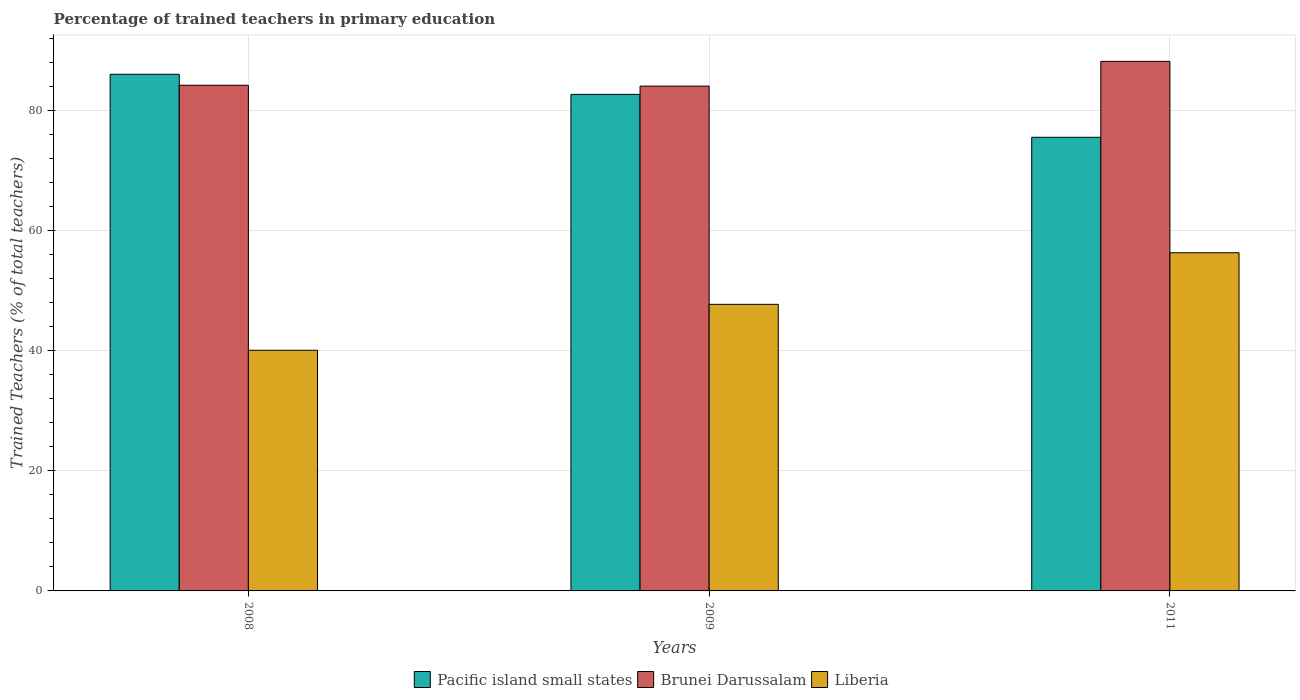How many groups of bars are there?
Offer a terse response. 3. Are the number of bars per tick equal to the number of legend labels?
Offer a terse response. Yes. Are the number of bars on each tick of the X-axis equal?
Keep it short and to the point. Yes. How many bars are there on the 2nd tick from the left?
Make the answer very short. 3. What is the percentage of trained teachers in Brunei Darussalam in 2008?
Give a very brief answer. 84.28. Across all years, what is the maximum percentage of trained teachers in Pacific island small states?
Ensure brevity in your answer.  86.11. Across all years, what is the minimum percentage of trained teachers in Brunei Darussalam?
Provide a succinct answer. 84.14. In which year was the percentage of trained teachers in Pacific island small states maximum?
Give a very brief answer. 2008. What is the total percentage of trained teachers in Pacific island small states in the graph?
Offer a very short reply. 244.49. What is the difference between the percentage of trained teachers in Brunei Darussalam in 2009 and that in 2011?
Keep it short and to the point. -4.13. What is the difference between the percentage of trained teachers in Liberia in 2011 and the percentage of trained teachers in Brunei Darussalam in 2009?
Keep it short and to the point. -27.77. What is the average percentage of trained teachers in Pacific island small states per year?
Give a very brief answer. 81.5. In the year 2008, what is the difference between the percentage of trained teachers in Pacific island small states and percentage of trained teachers in Liberia?
Offer a terse response. 46. What is the ratio of the percentage of trained teachers in Liberia in 2008 to that in 2009?
Your answer should be very brief. 0.84. Is the difference between the percentage of trained teachers in Pacific island small states in 2009 and 2011 greater than the difference between the percentage of trained teachers in Liberia in 2009 and 2011?
Offer a very short reply. Yes. What is the difference between the highest and the second highest percentage of trained teachers in Brunei Darussalam?
Offer a very short reply. 3.98. What is the difference between the highest and the lowest percentage of trained teachers in Brunei Darussalam?
Keep it short and to the point. 4.13. Is the sum of the percentage of trained teachers in Liberia in 2008 and 2011 greater than the maximum percentage of trained teachers in Brunei Darussalam across all years?
Your answer should be very brief. Yes. What does the 2nd bar from the left in 2011 represents?
Offer a very short reply. Brunei Darussalam. What does the 2nd bar from the right in 2009 represents?
Offer a terse response. Brunei Darussalam. How many bars are there?
Provide a succinct answer. 9. Are all the bars in the graph horizontal?
Your response must be concise. No. How many years are there in the graph?
Your response must be concise. 3. Does the graph contain grids?
Your answer should be compact. Yes. How many legend labels are there?
Keep it short and to the point. 3. How are the legend labels stacked?
Offer a very short reply. Horizontal. What is the title of the graph?
Keep it short and to the point. Percentage of trained teachers in primary education. What is the label or title of the Y-axis?
Provide a short and direct response. Trained Teachers (% of total teachers). What is the Trained Teachers (% of total teachers) of Pacific island small states in 2008?
Provide a short and direct response. 86.11. What is the Trained Teachers (% of total teachers) of Brunei Darussalam in 2008?
Your answer should be very brief. 84.28. What is the Trained Teachers (% of total teachers) in Liberia in 2008?
Keep it short and to the point. 40.11. What is the Trained Teachers (% of total teachers) of Pacific island small states in 2009?
Keep it short and to the point. 82.76. What is the Trained Teachers (% of total teachers) of Brunei Darussalam in 2009?
Give a very brief answer. 84.14. What is the Trained Teachers (% of total teachers) in Liberia in 2009?
Your answer should be very brief. 47.77. What is the Trained Teachers (% of total teachers) in Pacific island small states in 2011?
Your answer should be compact. 75.61. What is the Trained Teachers (% of total teachers) in Brunei Darussalam in 2011?
Your response must be concise. 88.27. What is the Trained Teachers (% of total teachers) in Liberia in 2011?
Provide a succinct answer. 56.37. Across all years, what is the maximum Trained Teachers (% of total teachers) in Pacific island small states?
Give a very brief answer. 86.11. Across all years, what is the maximum Trained Teachers (% of total teachers) in Brunei Darussalam?
Ensure brevity in your answer.  88.27. Across all years, what is the maximum Trained Teachers (% of total teachers) in Liberia?
Keep it short and to the point. 56.37. Across all years, what is the minimum Trained Teachers (% of total teachers) of Pacific island small states?
Your answer should be very brief. 75.61. Across all years, what is the minimum Trained Teachers (% of total teachers) of Brunei Darussalam?
Make the answer very short. 84.14. Across all years, what is the minimum Trained Teachers (% of total teachers) in Liberia?
Offer a terse response. 40.11. What is the total Trained Teachers (% of total teachers) in Pacific island small states in the graph?
Give a very brief answer. 244.49. What is the total Trained Teachers (% of total teachers) in Brunei Darussalam in the graph?
Ensure brevity in your answer.  256.69. What is the total Trained Teachers (% of total teachers) of Liberia in the graph?
Your answer should be compact. 144.25. What is the difference between the Trained Teachers (% of total teachers) in Pacific island small states in 2008 and that in 2009?
Offer a very short reply. 3.35. What is the difference between the Trained Teachers (% of total teachers) of Brunei Darussalam in 2008 and that in 2009?
Offer a very short reply. 0.14. What is the difference between the Trained Teachers (% of total teachers) in Liberia in 2008 and that in 2009?
Keep it short and to the point. -7.65. What is the difference between the Trained Teachers (% of total teachers) in Pacific island small states in 2008 and that in 2011?
Provide a succinct answer. 10.5. What is the difference between the Trained Teachers (% of total teachers) of Brunei Darussalam in 2008 and that in 2011?
Provide a succinct answer. -3.98. What is the difference between the Trained Teachers (% of total teachers) of Liberia in 2008 and that in 2011?
Your answer should be compact. -16.25. What is the difference between the Trained Teachers (% of total teachers) of Pacific island small states in 2009 and that in 2011?
Make the answer very short. 7.15. What is the difference between the Trained Teachers (% of total teachers) of Brunei Darussalam in 2009 and that in 2011?
Offer a very short reply. -4.13. What is the difference between the Trained Teachers (% of total teachers) in Liberia in 2009 and that in 2011?
Your answer should be very brief. -8.6. What is the difference between the Trained Teachers (% of total teachers) of Pacific island small states in 2008 and the Trained Teachers (% of total teachers) of Brunei Darussalam in 2009?
Ensure brevity in your answer.  1.97. What is the difference between the Trained Teachers (% of total teachers) of Pacific island small states in 2008 and the Trained Teachers (% of total teachers) of Liberia in 2009?
Your response must be concise. 38.35. What is the difference between the Trained Teachers (% of total teachers) of Brunei Darussalam in 2008 and the Trained Teachers (% of total teachers) of Liberia in 2009?
Make the answer very short. 36.52. What is the difference between the Trained Teachers (% of total teachers) in Pacific island small states in 2008 and the Trained Teachers (% of total teachers) in Brunei Darussalam in 2011?
Your answer should be compact. -2.15. What is the difference between the Trained Teachers (% of total teachers) of Pacific island small states in 2008 and the Trained Teachers (% of total teachers) of Liberia in 2011?
Provide a succinct answer. 29.75. What is the difference between the Trained Teachers (% of total teachers) in Brunei Darussalam in 2008 and the Trained Teachers (% of total teachers) in Liberia in 2011?
Ensure brevity in your answer.  27.92. What is the difference between the Trained Teachers (% of total teachers) in Pacific island small states in 2009 and the Trained Teachers (% of total teachers) in Brunei Darussalam in 2011?
Your response must be concise. -5.5. What is the difference between the Trained Teachers (% of total teachers) of Pacific island small states in 2009 and the Trained Teachers (% of total teachers) of Liberia in 2011?
Ensure brevity in your answer.  26.4. What is the difference between the Trained Teachers (% of total teachers) in Brunei Darussalam in 2009 and the Trained Teachers (% of total teachers) in Liberia in 2011?
Provide a short and direct response. 27.77. What is the average Trained Teachers (% of total teachers) in Pacific island small states per year?
Your answer should be compact. 81.5. What is the average Trained Teachers (% of total teachers) in Brunei Darussalam per year?
Give a very brief answer. 85.56. What is the average Trained Teachers (% of total teachers) in Liberia per year?
Offer a very short reply. 48.08. In the year 2008, what is the difference between the Trained Teachers (% of total teachers) in Pacific island small states and Trained Teachers (% of total teachers) in Brunei Darussalam?
Offer a terse response. 1.83. In the year 2008, what is the difference between the Trained Teachers (% of total teachers) of Pacific island small states and Trained Teachers (% of total teachers) of Liberia?
Ensure brevity in your answer.  46. In the year 2008, what is the difference between the Trained Teachers (% of total teachers) in Brunei Darussalam and Trained Teachers (% of total teachers) in Liberia?
Keep it short and to the point. 44.17. In the year 2009, what is the difference between the Trained Teachers (% of total teachers) in Pacific island small states and Trained Teachers (% of total teachers) in Brunei Darussalam?
Your response must be concise. -1.38. In the year 2009, what is the difference between the Trained Teachers (% of total teachers) of Pacific island small states and Trained Teachers (% of total teachers) of Liberia?
Your answer should be compact. 35. In the year 2009, what is the difference between the Trained Teachers (% of total teachers) in Brunei Darussalam and Trained Teachers (% of total teachers) in Liberia?
Your answer should be very brief. 36.37. In the year 2011, what is the difference between the Trained Teachers (% of total teachers) of Pacific island small states and Trained Teachers (% of total teachers) of Brunei Darussalam?
Provide a succinct answer. -12.66. In the year 2011, what is the difference between the Trained Teachers (% of total teachers) in Pacific island small states and Trained Teachers (% of total teachers) in Liberia?
Offer a very short reply. 19.24. In the year 2011, what is the difference between the Trained Teachers (% of total teachers) in Brunei Darussalam and Trained Teachers (% of total teachers) in Liberia?
Your answer should be very brief. 31.9. What is the ratio of the Trained Teachers (% of total teachers) in Pacific island small states in 2008 to that in 2009?
Provide a succinct answer. 1.04. What is the ratio of the Trained Teachers (% of total teachers) in Liberia in 2008 to that in 2009?
Your response must be concise. 0.84. What is the ratio of the Trained Teachers (% of total teachers) in Pacific island small states in 2008 to that in 2011?
Give a very brief answer. 1.14. What is the ratio of the Trained Teachers (% of total teachers) of Brunei Darussalam in 2008 to that in 2011?
Provide a succinct answer. 0.95. What is the ratio of the Trained Teachers (% of total teachers) in Liberia in 2008 to that in 2011?
Your response must be concise. 0.71. What is the ratio of the Trained Teachers (% of total teachers) in Pacific island small states in 2009 to that in 2011?
Make the answer very short. 1.09. What is the ratio of the Trained Teachers (% of total teachers) in Brunei Darussalam in 2009 to that in 2011?
Make the answer very short. 0.95. What is the ratio of the Trained Teachers (% of total teachers) in Liberia in 2009 to that in 2011?
Provide a short and direct response. 0.85. What is the difference between the highest and the second highest Trained Teachers (% of total teachers) of Pacific island small states?
Provide a succinct answer. 3.35. What is the difference between the highest and the second highest Trained Teachers (% of total teachers) of Brunei Darussalam?
Your answer should be compact. 3.98. What is the difference between the highest and the second highest Trained Teachers (% of total teachers) of Liberia?
Your response must be concise. 8.6. What is the difference between the highest and the lowest Trained Teachers (% of total teachers) in Pacific island small states?
Keep it short and to the point. 10.5. What is the difference between the highest and the lowest Trained Teachers (% of total teachers) in Brunei Darussalam?
Your answer should be very brief. 4.13. What is the difference between the highest and the lowest Trained Teachers (% of total teachers) of Liberia?
Offer a very short reply. 16.25. 